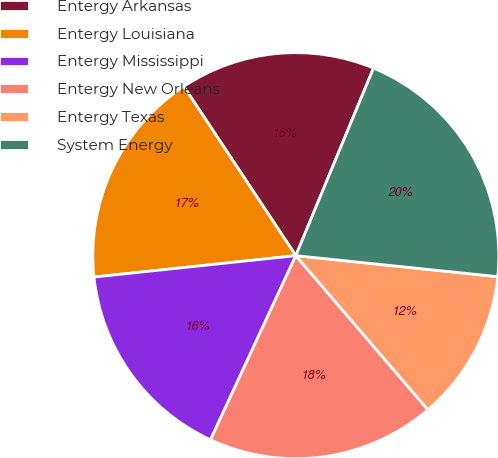Convert chart to OTSL. <chart><loc_0><loc_0><loc_500><loc_500><pie_chart><fcel>Entergy Arkansas<fcel>Entergy Louisiana<fcel>Entergy Mississippi<fcel>Entergy New Orleans<fcel>Entergy Texas<fcel>System Energy<nl><fcel>15.56%<fcel>17.37%<fcel>16.41%<fcel>18.18%<fcel>12.07%<fcel>20.4%<nl></chart> 